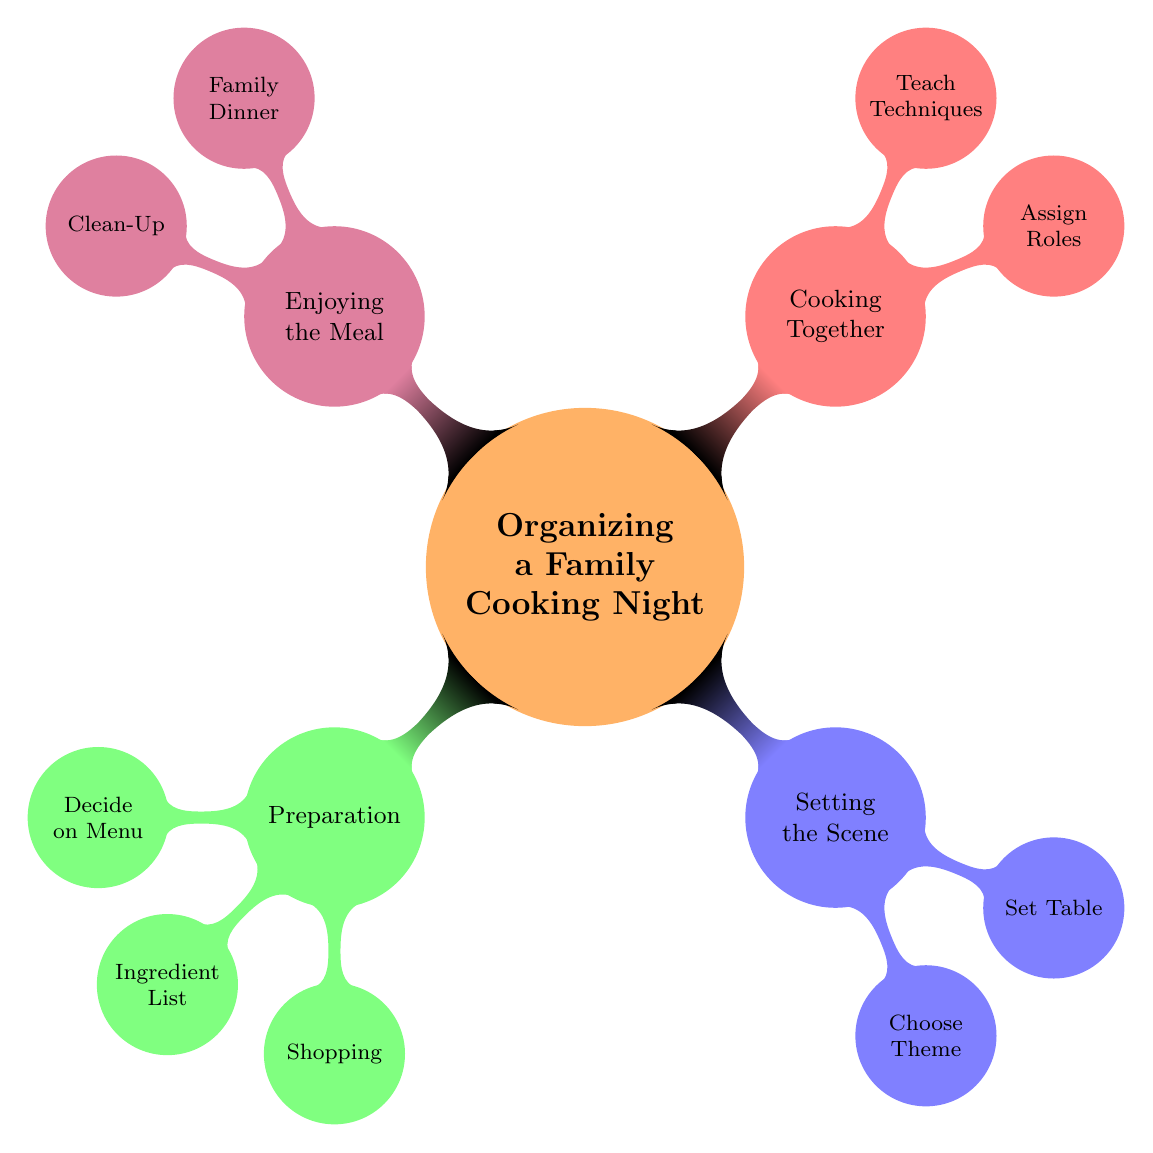What are the main categories in the diagram? The diagram is divided into four main categories: Preparation, Setting the Scene, Cooking Together, and Enjoying the Meal. Each category has sub-nodes associated with it.
Answer: Preparation, Setting the Scene, Cooking Together, Enjoying the Meal How many choices are listed under "Decide on a Menu"? Under the "Decide on a Menu" node, there are three specific choices: Appetizers, Main Course, and Desserts.
Answer: 3 What role is assigned in the "Cooking Together" section? The "Cooking Together" section has multiple assigned roles, one of which is "Preparing Desserts." This is a specific task allocated to a family member during the cooking process.
Answer: Preparing Desserts Which theme option is associated with "Setting the Scene"? In the "Setting the Scene" section, one of the theme options listed is "Italian Night." This indicates a thematic choice for the family cooking night.
Answer: Italian Night What is one of the activities highlighted in "Enjoying the Meal"? One of the activities in "Enjoying the Meal" is "Sharing Stories." This implies a family bonding activity that can occur during the dinner.
Answer: Sharing Stories What is the focus of the "Ingredient List" in the Preparation category? The "Ingredient List" node focuses on various types of ingredients needed for cooking, including Fresh Vegetables, Spices & Herbs, Proteins, Grains, and Dairy.
Answer: Fresh Vegetables, Spices & Herbs, Proteins, Grains, Dairy Which node emphasizes a collaborative aspect of the cooking night? The "Cooking Together" node emphasizes collaboration, as it pertains to actively assigning roles and teaching cooking techniques to family members.
Answer: Cooking Together How many total child nodes are there under "Setting the Scene"? The "Setting the Scene" category has two child nodes: Choosing a Theme and Setting the Table, totaling to two nodes.
Answer: 2 